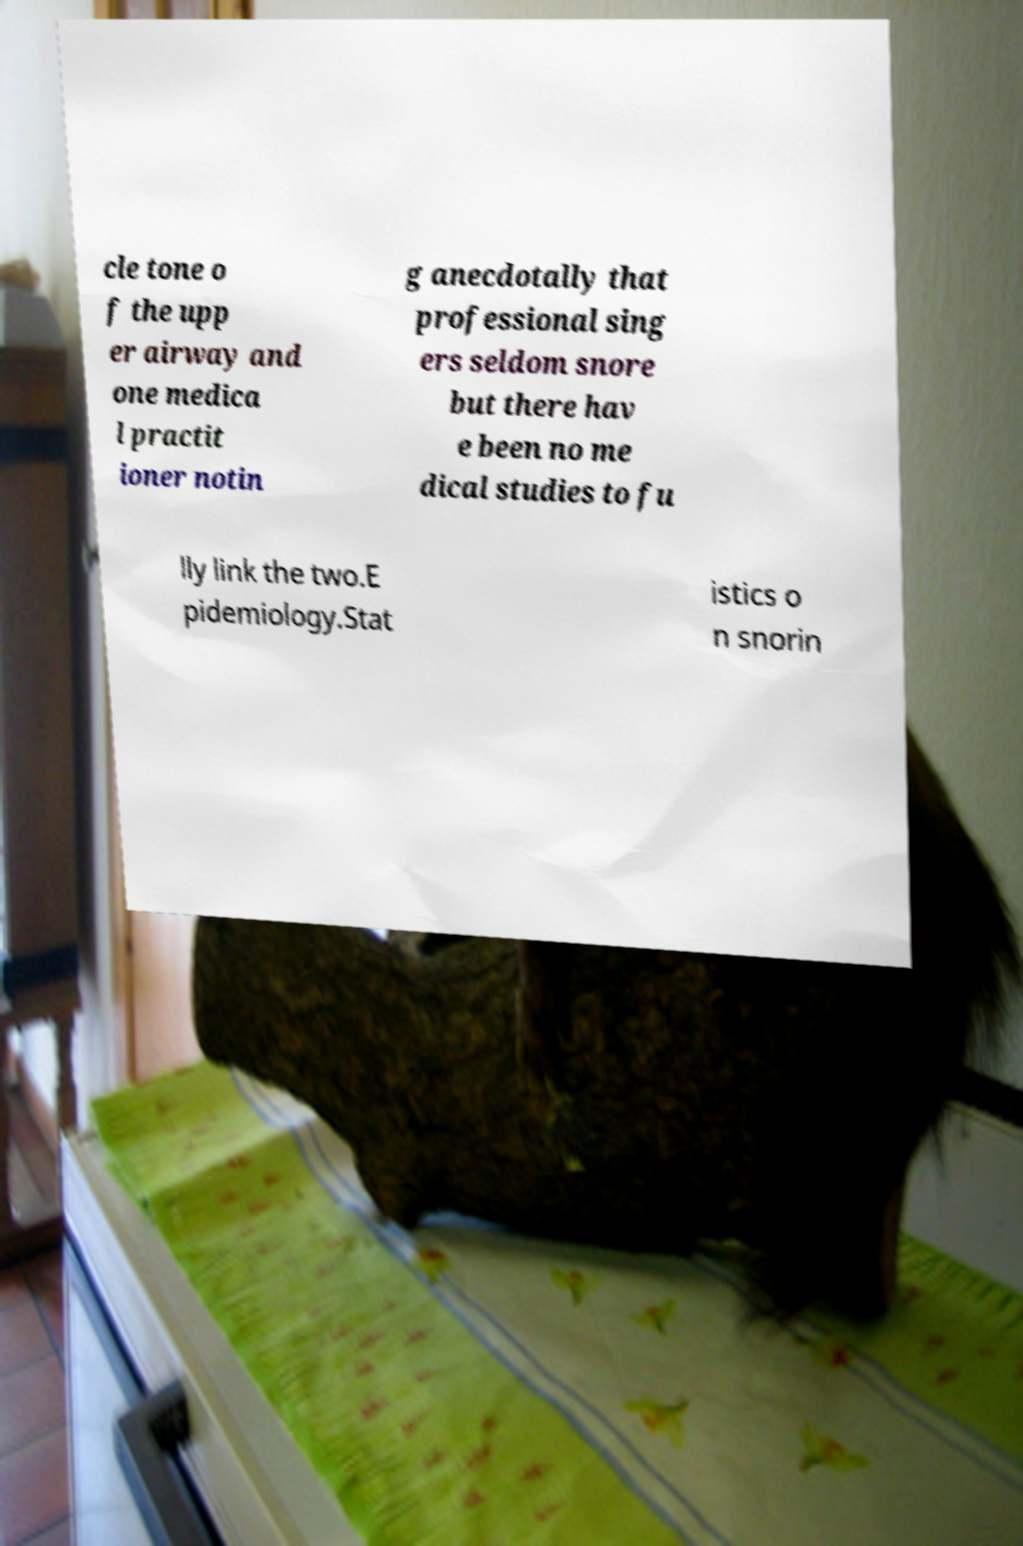I need the written content from this picture converted into text. Can you do that? cle tone o f the upp er airway and one medica l practit ioner notin g anecdotally that professional sing ers seldom snore but there hav e been no me dical studies to fu lly link the two.E pidemiology.Stat istics o n snorin 